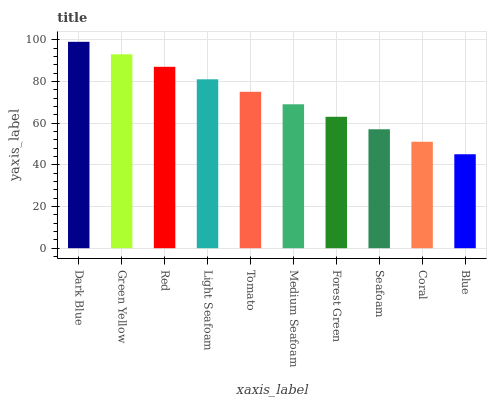Is Blue the minimum?
Answer yes or no. Yes. Is Dark Blue the maximum?
Answer yes or no. Yes. Is Green Yellow the minimum?
Answer yes or no. No. Is Green Yellow the maximum?
Answer yes or no. No. Is Dark Blue greater than Green Yellow?
Answer yes or no. Yes. Is Green Yellow less than Dark Blue?
Answer yes or no. Yes. Is Green Yellow greater than Dark Blue?
Answer yes or no. No. Is Dark Blue less than Green Yellow?
Answer yes or no. No. Is Tomato the high median?
Answer yes or no. Yes. Is Medium Seafoam the low median?
Answer yes or no. Yes. Is Medium Seafoam the high median?
Answer yes or no. No. Is Red the low median?
Answer yes or no. No. 